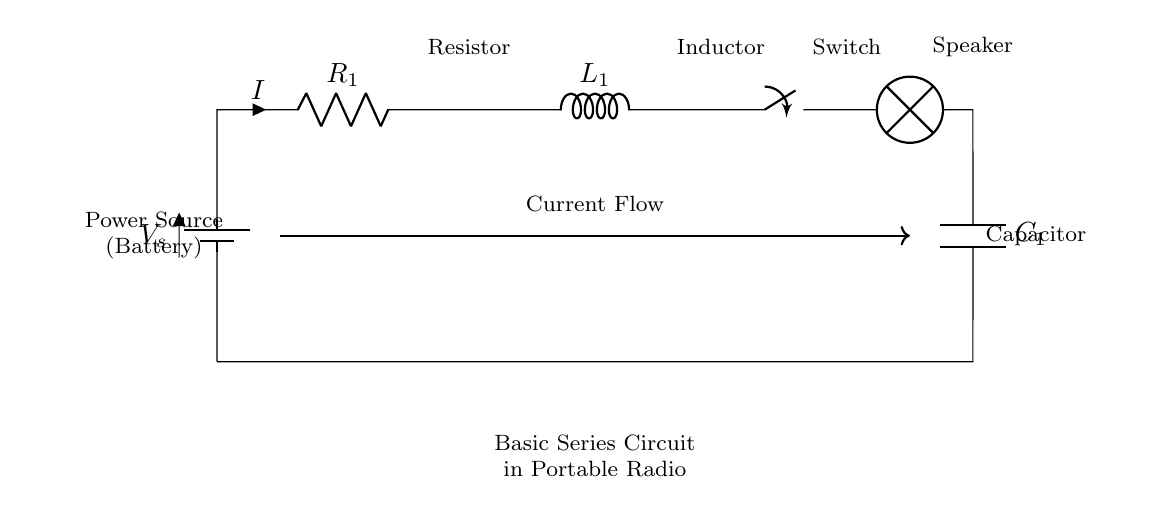What is the power source in this circuit? The power source is represented by the battery symbol in the diagram. It provides the necessary voltage for the circuit to function.
Answer: Battery What component is represented by the label R? The label R indicates a resistor in the circuit, shown in series and responsible for limiting current flow.
Answer: Resistor What component is connected to the speaker? The speaker is connected directly to the output of the circuit, indicating it is the element that converts electrical energy into sound.
Answer: Speaker How many inductors are present in this circuit? There is only one inductor labeled L, which is designed to store energy in a magnetic field when current passes through it.
Answer: One What happens when the switch is open? When the switch is open, it interrupts the current flow in the circuit, meaning no current can travel to the lamp and the radio will not operate.
Answer: Current stops If the resistance is increased, what happens to the current? According to Ohm's Law, if the resistance increases while the voltage remains constant, the current will decrease. Thus, increasing resistance impacts the current negatively.
Answer: Decreases What is the role of the capacitor in this circuit? The capacitor, labeled C, is used for smoothing voltage fluctuations and storing charge, which helps stabilize the circuit operation.
Answer: Store charge 